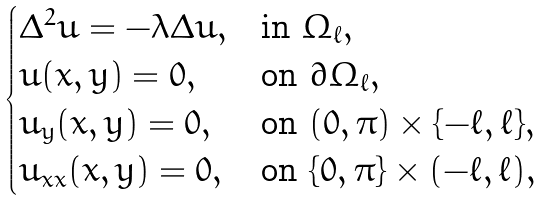Convert formula to latex. <formula><loc_0><loc_0><loc_500><loc_500>\begin{cases} \Delta ^ { 2 } u = - \lambda \Delta u , & \text {in } \Omega _ { \ell } , \\ u ( x , y ) = 0 , & \text {on } \partial \Omega _ { \ell } , \\ u _ { y } ( x , y ) = 0 , & \text {on } ( 0 , \pi ) \times \{ - \ell , \ell \} , \\ u _ { x x } ( x , y ) = 0 , & \text {on } \{ 0 , \pi \} \times ( - \ell , \ell ) , \end{cases}</formula> 